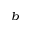<formula> <loc_0><loc_0><loc_500><loc_500>^ { b }</formula> 